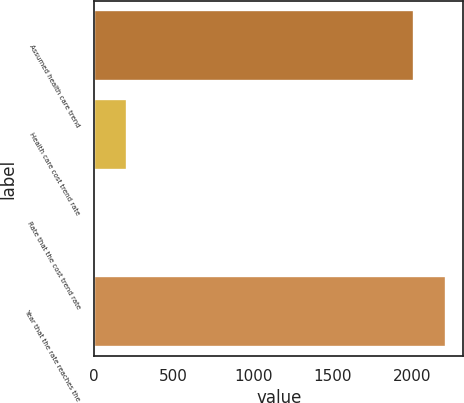Convert chart. <chart><loc_0><loc_0><loc_500><loc_500><bar_chart><fcel>Assumed health care trend<fcel>Health care cost trend rate<fcel>Rate that the cost trend rate<fcel>Year that the rate reaches the<nl><fcel>2011<fcel>206.3<fcel>5<fcel>2212.3<nl></chart> 